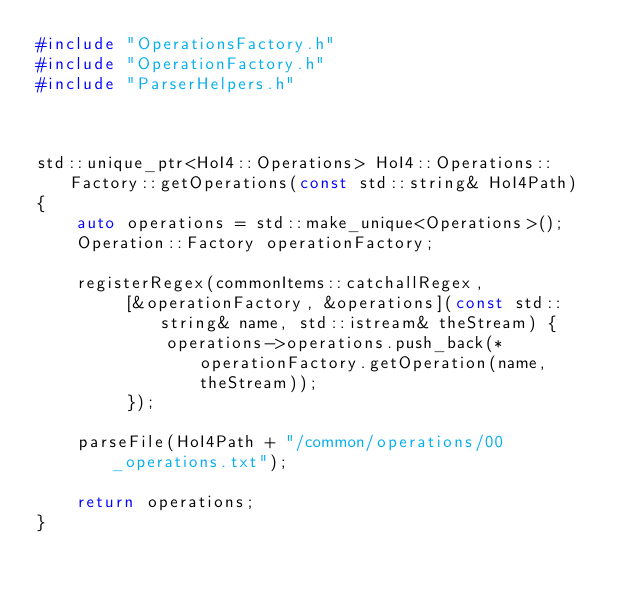<code> <loc_0><loc_0><loc_500><loc_500><_C++_>#include "OperationsFactory.h"
#include "OperationFactory.h"
#include "ParserHelpers.h"



std::unique_ptr<HoI4::Operations> HoI4::Operations::Factory::getOperations(const std::string& HoI4Path)
{
	auto operations = std::make_unique<Operations>();
	Operation::Factory operationFactory;

	registerRegex(commonItems::catchallRegex,
		 [&operationFactory, &operations](const std::string& name, std::istream& theStream) {
			 operations->operations.push_back(*operationFactory.getOperation(name, theStream));
		 });

	parseFile(HoI4Path + "/common/operations/00_operations.txt");

	return operations;
}</code> 